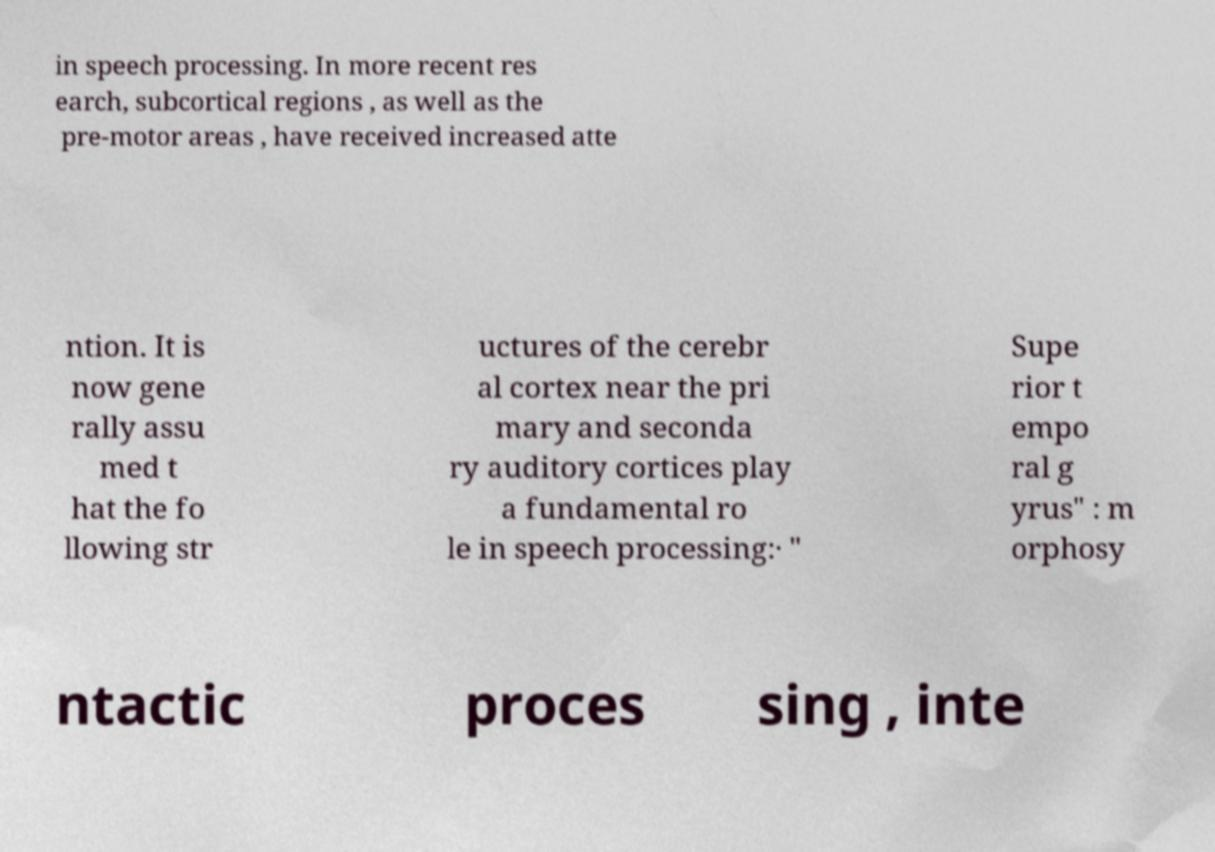Could you extract and type out the text from this image? in speech processing. In more recent res earch, subcortical regions , as well as the pre-motor areas , have received increased atte ntion. It is now gene rally assu med t hat the fo llowing str uctures of the cerebr al cortex near the pri mary and seconda ry auditory cortices play a fundamental ro le in speech processing:· " Supe rior t empo ral g yrus" : m orphosy ntactic proces sing , inte 